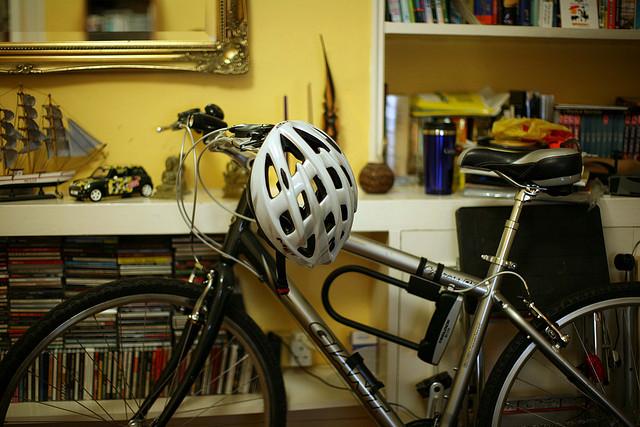Are the objects on the bottom shelf books?
Give a very brief answer. No. Is this inside?
Give a very brief answer. Yes. Is this cycle unusual?
Be succinct. No. Do most people keep their bicycle in this room?
Answer briefly. No. Is riding a bike good exercise?
Be succinct. Yes. 